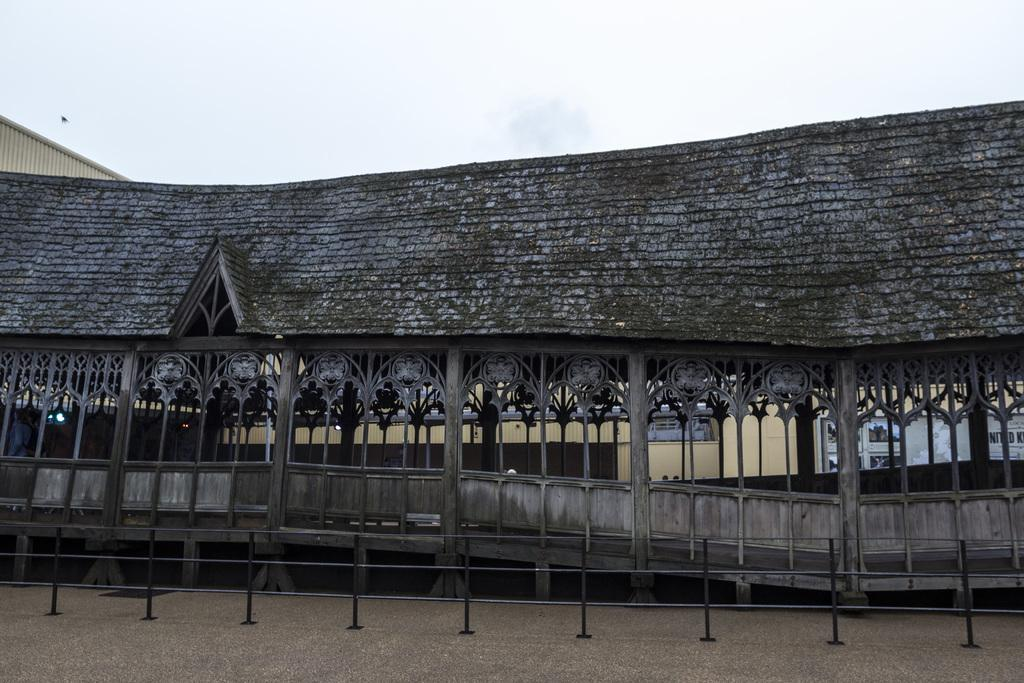What type of structure is present in the image? There is a building in the image. What part of the building can be seen at the bottom of the image? The floor is visible at the bottom of the image. What feature is present at the bottom of the image to provide safety or support? There is a railing at the bottom of the image. What is visible at the top of the image? The sky is visible at the top of the image. Can you describe the reaction of the vein when the building shakes in the image? There is no indication that the building is shaking or that there are veins present in the image. 